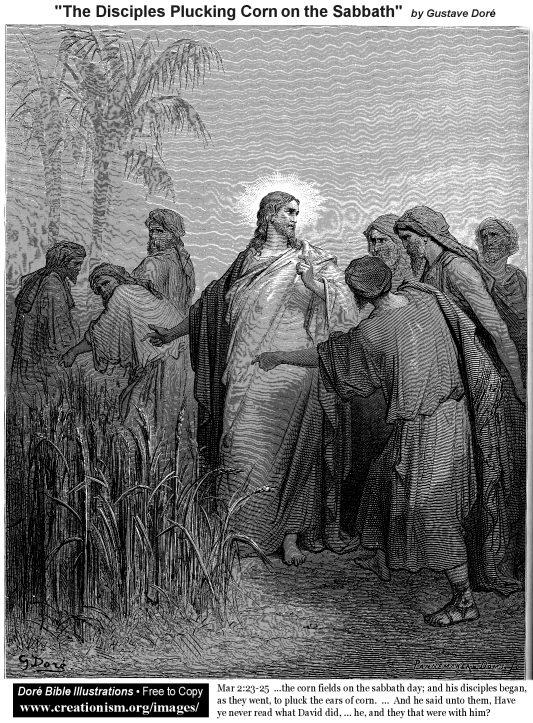What's happening in the scene? The image is a black and white illustration by Gustave Doré, titled "The Disciples Plucking Corn on the Sabbath." It represents a realistic art style within the genre of religious art. The scene depicts a field of tall corn plants where a group of men are gathered around a central figure, likely Jesus Christ, who is surrounded by his disciples. Each figure is depicted with long beards and robes, adding to the historical context of the image. The illustration is highly detailed, featuring intricate shading and cross-hatching techniques that lend depth and texture. The monochromatic color scheme enhances the dramatic effect, despite the absence of color, making the image rich in detail and narrative. The scene captures a moment of religious significance, portraying the disciples plucking corn on the Sabbath under Jesus's watchful guidance. 